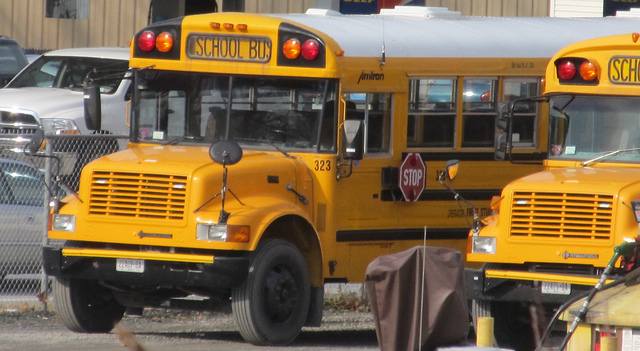Identify and read out the text in this image. SCHOOL BUS 323 STOP SCH 